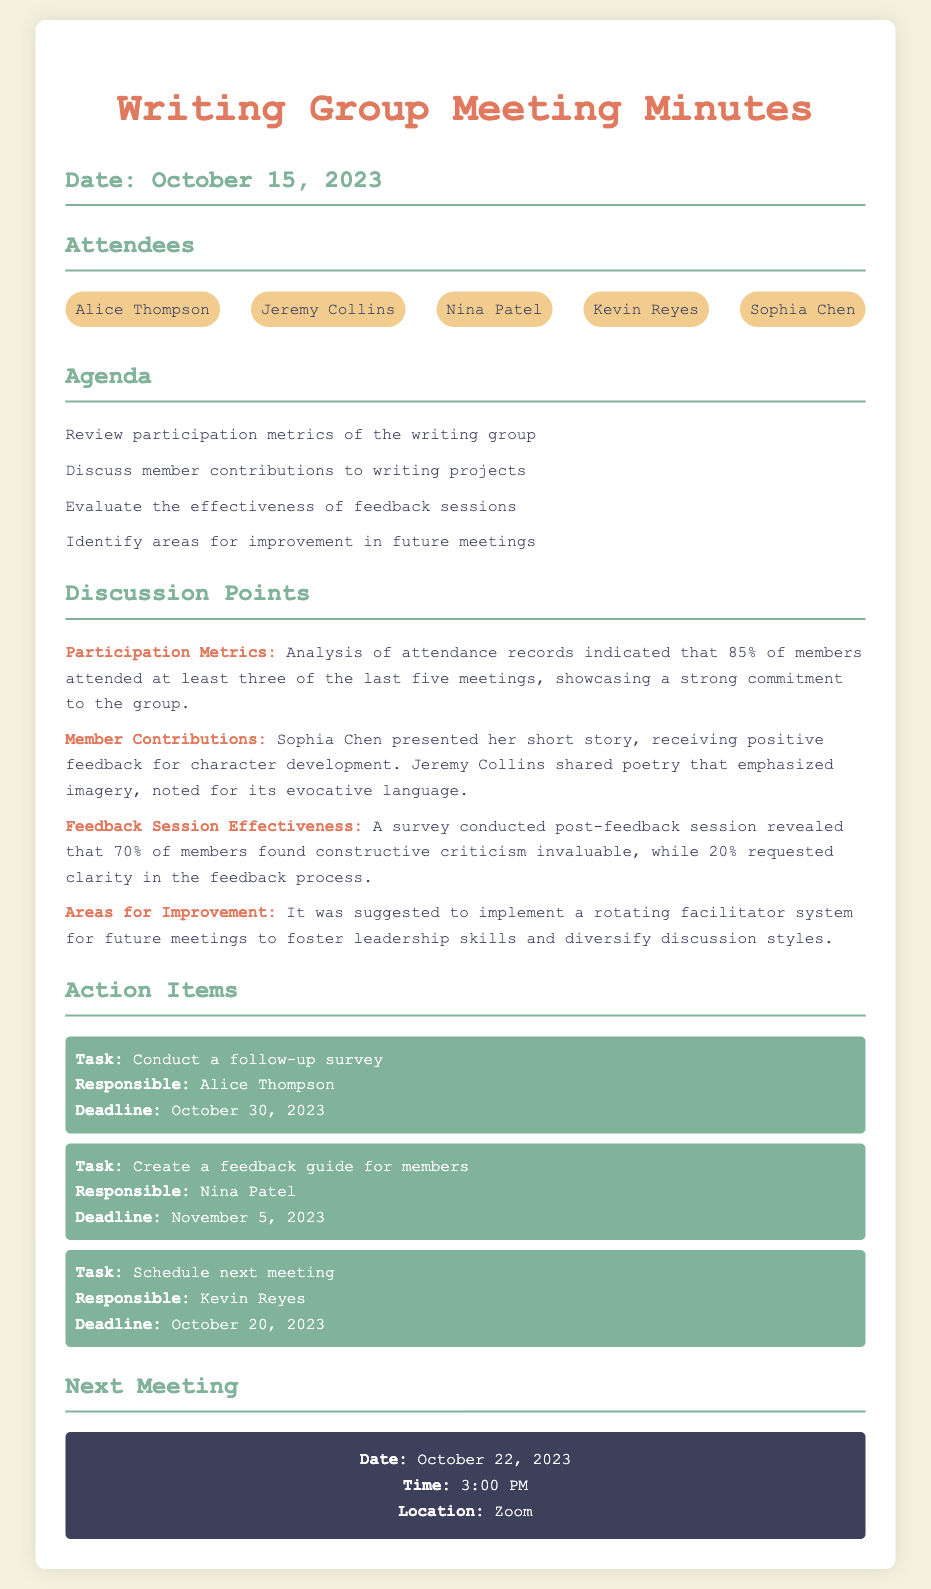What percentage of members attended at least three of the last five meetings? The document states that 85% of members attended at least three of the last five meetings, indicating strong commitment.
Answer: 85% Who is responsible for conducting a follow-up survey? The action item indicates that Alice Thompson is responsible for this task.
Answer: Alice Thompson What date is the next meeting scheduled for? The document specifies that the next meeting is on October 22, 2023.
Answer: October 22, 2023 What percentage of members found constructive criticism invaluable? According to the feedback session effectiveness data, 70% of members found constructive criticism invaluable.
Answer: 70% What specific improvement was suggested for future meetings? The discussion points note the suggestion to implement a rotating facilitator system for future meetings.
Answer: Rotating facilitator system Who presented a short story during the meeting? The document indicates that Sophia Chen presented her short story, receiving positive feedback.
Answer: Sophia Chen What deadline is set for creating a feedback guide? The action items specify that the deadline for creating a feedback guide is November 5, 2023.
Answer: November 5, 2023 How many attendees were present at the meeting? There were five attendees listed in the document.
Answer: Five 